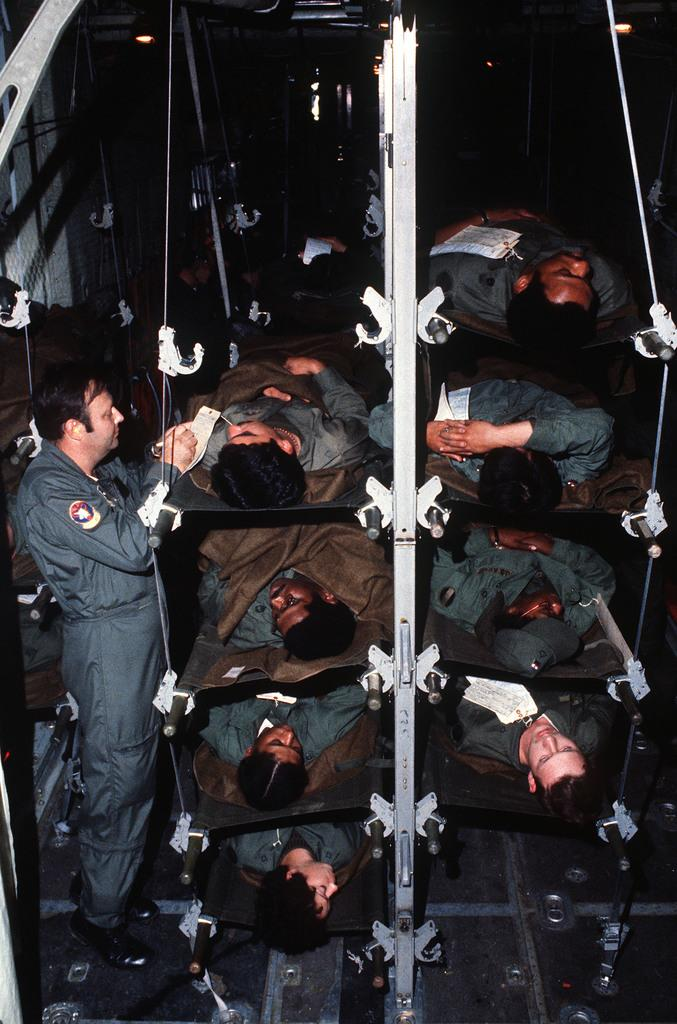What is the main subject of the image? The main subject of the image is many soldiers. What are the soldiers doing in the image? The soldiers are laying on beds in the image. How are the beds arranged in the image? The beds are stacked one over the other in the image. Can you describe the person standing in the image? There is a man standing on the left side of the image. What type of camera can be seen in the image? There is no camera present in the image. What is the opinion of the box on the right side of the image? There is no box present in the image, so it is not possible to determine its opinion. 